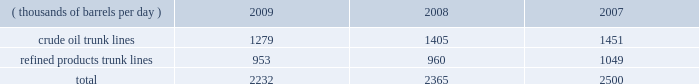Pipeline transportation 2013 we own a system of pipelines through marathon pipe line llc ( 201cmpl 201d ) and ohio river pipe line llc ( 201corpl 201d ) , our wholly-owned subsidiaries .
Our pipeline systems transport crude oil and refined products primarily in the midwest and gulf coast regions to our refineries , our terminals and other pipeline systems .
Our mpl and orpl wholly-owned and undivided interest common carrier systems consist of 1737 miles of crude oil lines and 1825 miles of refined product lines comprising 32 systems located in 11 states .
The mpl common carrier pipeline network is one of the largest petroleum pipeline systems in the united states , based on total barrels delivered .
Our common carrier pipeline systems are subject to state and federal energy regulatory commission regulations and guidelines , including published tariffs for the transportation of crude oil and refined products .
Third parties generated 13 percent of the crude oil and refined product shipments on our mpl and orpl common carrier pipelines in 2009 .
Our mpl and orpl common carrier pipelines transported the volumes shown in the table for each of the last three years .
Pipeline barrels handled ( thousands of barrels per day ) 2009 2008 2007 .
We also own 196 miles of private crude oil pipelines and 850 miles of private refined products pipelines , and we lease 217 miles of common carrier refined product pipelines .
We have partial ownership interests in several pipeline companies that have approximately 780 miles of crude oil pipelines and 3600 miles of refined products pipelines , including about 970 miles operated by mpl .
In addition , mpl operates most of our private pipelines and 985 miles of crude oil and 160 miles of natural gas pipelines owned by our e&p segment .
Our major refined product pipelines include the owned and operated cardinal products pipeline and the wabash pipeline .
The cardinal products pipeline delivers refined products from kenova , west virginia , to columbus , ohio .
The wabash pipeline system delivers product from robinson , illinois , to various terminals in the area of chicago , illinois .
Other significant refined product pipelines owned and operated by mpl extend from : robinson , illinois , to louisville , kentucky ; garyville , louisiana , to zachary , louisiana ; and texas city , texas , to pasadena , texas .
In addition , as of december 31 , 2009 , we had interests in the following refined product pipelines : 2022 65 percent undivided ownership interest in the louisville-lexington system , a petroleum products pipeline system extending from louisville to lexington , kentucky ; 2022 60 percent interest in muskegon pipeline llc , which owns a refined products pipeline extending from griffith , indiana , to north muskegon , michigan ; 2022 50 percent interest in centennial pipeline llc , which owns a refined products system connecting the gulf coast region with the midwest market ; 2022 17 percent interest in explorer pipeline company , a refined products pipeline system extending from the gulf coast to the midwest ; and 2022 6 percent interest in wolverine pipe line company , a refined products pipeline system extending from chicago , illinois , to toledo , ohio .
Our major owned and operated crude oil lines run from : patoka , illinois , to catlettsburg , kentucky ; patoka , illinois , to robinson , illinois ; patoka , illinois , to lima , ohio ; lima , ohio to canton , ohio ; samaria , michigan , to detroit , michigan ; and st .
James , louisiana , to garyville , louisiana .
As of december 31 , 2009 , we had interests in the following crude oil pipelines : 2022 51 percent interest in loop llc , the owner and operator of loop , which is the only u.s .
Deepwater oil port , located 18 miles off the coast of louisiana , and a crude oil pipeline connecting the port facility to storage caverns and tanks at clovelly , louisiana ; 2022 59 percent interest in locap llc , which owns a crude oil pipeline connecting loop and the capline system; .
What was the greatest yearly production of crude oil trunk lines? 
Computations: table_max(crude oil trunk lines, none)
Answer: 1451.0. Pipeline transportation 2013 we own a system of pipelines through marathon pipe line llc ( 201cmpl 201d ) and ohio river pipe line llc ( 201corpl 201d ) , our wholly-owned subsidiaries .
Our pipeline systems transport crude oil and refined products primarily in the midwest and gulf coast regions to our refineries , our terminals and other pipeline systems .
Our mpl and orpl wholly-owned and undivided interest common carrier systems consist of 1737 miles of crude oil lines and 1825 miles of refined product lines comprising 32 systems located in 11 states .
The mpl common carrier pipeline network is one of the largest petroleum pipeline systems in the united states , based on total barrels delivered .
Our common carrier pipeline systems are subject to state and federal energy regulatory commission regulations and guidelines , including published tariffs for the transportation of crude oil and refined products .
Third parties generated 13 percent of the crude oil and refined product shipments on our mpl and orpl common carrier pipelines in 2009 .
Our mpl and orpl common carrier pipelines transported the volumes shown in the table for each of the last three years .
Pipeline barrels handled ( thousands of barrels per day ) 2009 2008 2007 .
We also own 196 miles of private crude oil pipelines and 850 miles of private refined products pipelines , and we lease 217 miles of common carrier refined product pipelines .
We have partial ownership interests in several pipeline companies that have approximately 780 miles of crude oil pipelines and 3600 miles of refined products pipelines , including about 970 miles operated by mpl .
In addition , mpl operates most of our private pipelines and 985 miles of crude oil and 160 miles of natural gas pipelines owned by our e&p segment .
Our major refined product pipelines include the owned and operated cardinal products pipeline and the wabash pipeline .
The cardinal products pipeline delivers refined products from kenova , west virginia , to columbus , ohio .
The wabash pipeline system delivers product from robinson , illinois , to various terminals in the area of chicago , illinois .
Other significant refined product pipelines owned and operated by mpl extend from : robinson , illinois , to louisville , kentucky ; garyville , louisiana , to zachary , louisiana ; and texas city , texas , to pasadena , texas .
In addition , as of december 31 , 2009 , we had interests in the following refined product pipelines : 2022 65 percent undivided ownership interest in the louisville-lexington system , a petroleum products pipeline system extending from louisville to lexington , kentucky ; 2022 60 percent interest in muskegon pipeline llc , which owns a refined products pipeline extending from griffith , indiana , to north muskegon , michigan ; 2022 50 percent interest in centennial pipeline llc , which owns a refined products system connecting the gulf coast region with the midwest market ; 2022 17 percent interest in explorer pipeline company , a refined products pipeline system extending from the gulf coast to the midwest ; and 2022 6 percent interest in wolverine pipe line company , a refined products pipeline system extending from chicago , illinois , to toledo , ohio .
Our major owned and operated crude oil lines run from : patoka , illinois , to catlettsburg , kentucky ; patoka , illinois , to robinson , illinois ; patoka , illinois , to lima , ohio ; lima , ohio to canton , ohio ; samaria , michigan , to detroit , michigan ; and st .
James , louisiana , to garyville , louisiana .
As of december 31 , 2009 , we had interests in the following crude oil pipelines : 2022 51 percent interest in loop llc , the owner and operator of loop , which is the only u.s .
Deepwater oil port , located 18 miles off the coast of louisiana , and a crude oil pipeline connecting the port facility to storage caverns and tanks at clovelly , louisiana ; 2022 59 percent interest in locap llc , which owns a crude oil pipeline connecting loop and the capline system; .
In 2009 what percentage of pipeline barrels handled consisted of crude oil trunk lines? 
Computations: (1279 / 2232)
Answer: 0.57303. Pipeline transportation 2013 we own a system of pipelines through marathon pipe line llc ( 201cmpl 201d ) and ohio river pipe line llc ( 201corpl 201d ) , our wholly-owned subsidiaries .
Our pipeline systems transport crude oil and refined products primarily in the midwest and gulf coast regions to our refineries , our terminals and other pipeline systems .
Our mpl and orpl wholly-owned and undivided interest common carrier systems consist of 1737 miles of crude oil lines and 1825 miles of refined product lines comprising 32 systems located in 11 states .
The mpl common carrier pipeline network is one of the largest petroleum pipeline systems in the united states , based on total barrels delivered .
Our common carrier pipeline systems are subject to state and federal energy regulatory commission regulations and guidelines , including published tariffs for the transportation of crude oil and refined products .
Third parties generated 13 percent of the crude oil and refined product shipments on our mpl and orpl common carrier pipelines in 2009 .
Our mpl and orpl common carrier pipelines transported the volumes shown in the table for each of the last three years .
Pipeline barrels handled ( thousands of barrels per day ) 2009 2008 2007 .
We also own 196 miles of private crude oil pipelines and 850 miles of private refined products pipelines , and we lease 217 miles of common carrier refined product pipelines .
We have partial ownership interests in several pipeline companies that have approximately 780 miles of crude oil pipelines and 3600 miles of refined products pipelines , including about 970 miles operated by mpl .
In addition , mpl operates most of our private pipelines and 985 miles of crude oil and 160 miles of natural gas pipelines owned by our e&p segment .
Our major refined product pipelines include the owned and operated cardinal products pipeline and the wabash pipeline .
The cardinal products pipeline delivers refined products from kenova , west virginia , to columbus , ohio .
The wabash pipeline system delivers product from robinson , illinois , to various terminals in the area of chicago , illinois .
Other significant refined product pipelines owned and operated by mpl extend from : robinson , illinois , to louisville , kentucky ; garyville , louisiana , to zachary , louisiana ; and texas city , texas , to pasadena , texas .
In addition , as of december 31 , 2009 , we had interests in the following refined product pipelines : 2022 65 percent undivided ownership interest in the louisville-lexington system , a petroleum products pipeline system extending from louisville to lexington , kentucky ; 2022 60 percent interest in muskegon pipeline llc , which owns a refined products pipeline extending from griffith , indiana , to north muskegon , michigan ; 2022 50 percent interest in centennial pipeline llc , which owns a refined products system connecting the gulf coast region with the midwest market ; 2022 17 percent interest in explorer pipeline company , a refined products pipeline system extending from the gulf coast to the midwest ; and 2022 6 percent interest in wolverine pipe line company , a refined products pipeline system extending from chicago , illinois , to toledo , ohio .
Our major owned and operated crude oil lines run from : patoka , illinois , to catlettsburg , kentucky ; patoka , illinois , to robinson , illinois ; patoka , illinois , to lima , ohio ; lima , ohio to canton , ohio ; samaria , michigan , to detroit , michigan ; and st .
James , louisiana , to garyville , louisiana .
As of december 31 , 2009 , we had interests in the following crude oil pipelines : 2022 51 percent interest in loop llc , the owner and operator of loop , which is the only u.s .
Deepwater oil port , located 18 miles off the coast of louisiana , and a crude oil pipeline connecting the port facility to storage caverns and tanks at clovelly , louisiana ; 2022 59 percent interest in locap llc , which owns a crude oil pipeline connecting loop and the capline system; .
What was the total refined products trunk lines production in tbd for the three year period? 
Computations: ((953 + 960) + 1049)
Answer: 2962.0. 